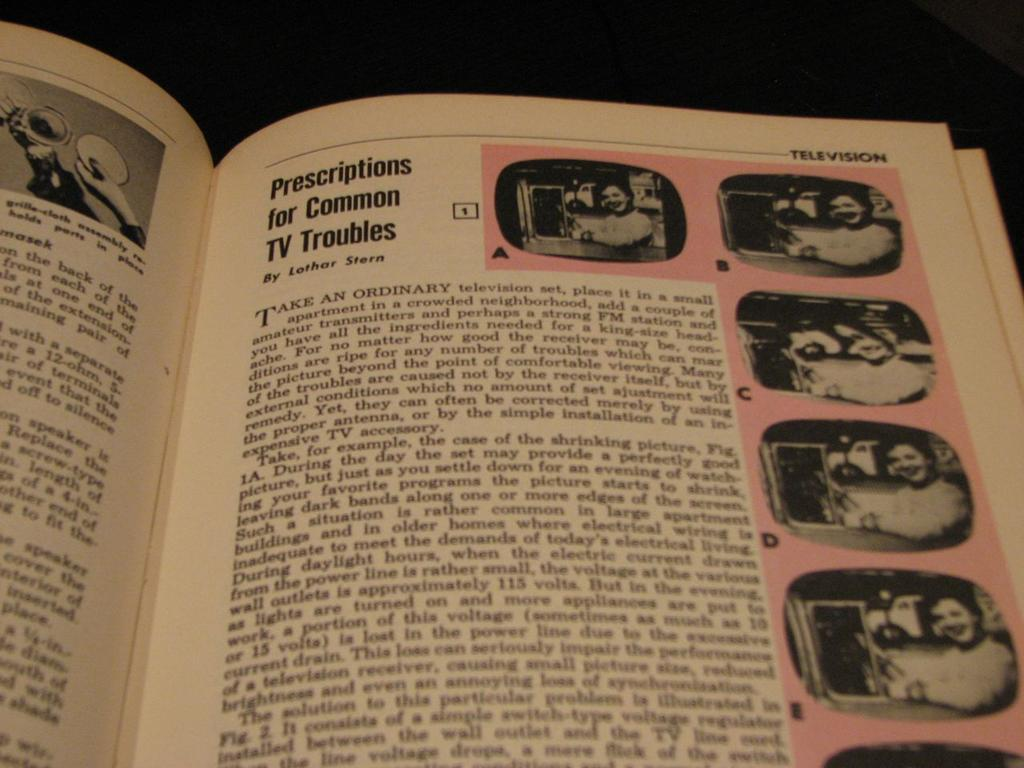<image>
Give a short and clear explanation of the subsequent image. A book opened to the page regarding prescriptions for common TV troubles. 